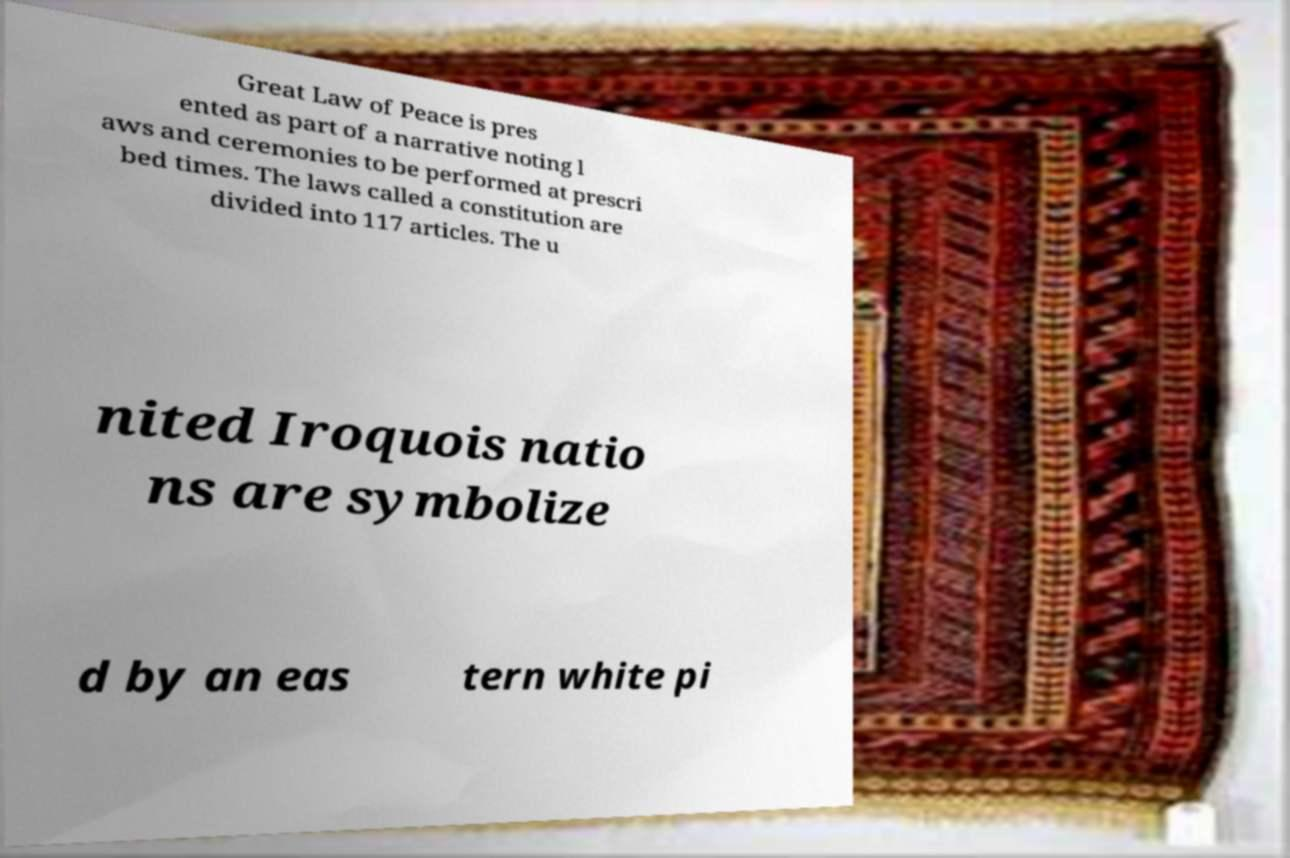Please read and relay the text visible in this image. What does it say? Great Law of Peace is pres ented as part of a narrative noting l aws and ceremonies to be performed at prescri bed times. The laws called a constitution are divided into 117 articles. The u nited Iroquois natio ns are symbolize d by an eas tern white pi 